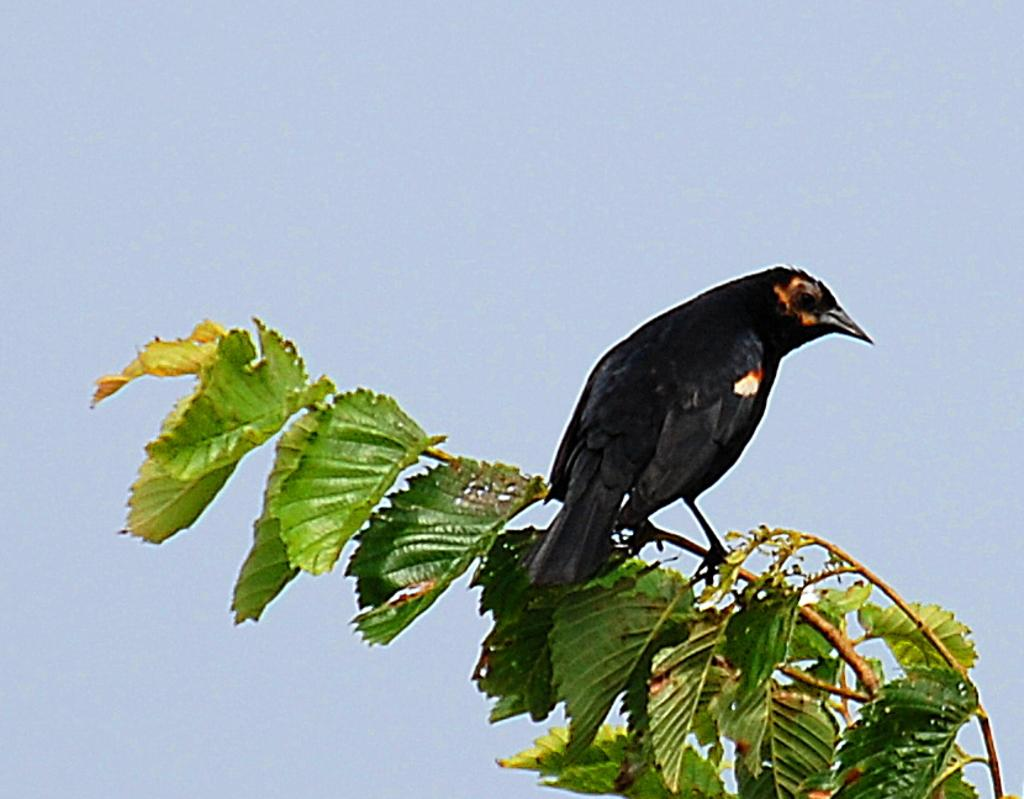What type of animal is in the foreground of the image? There is a black bird in the foreground of the image. Where is the bird located? The bird is on a branch. What can be seen on the branch besides the bird? There are leaves on the branch. What is visible in the background of the image? The sky is visible in the background of the image. What type of scent can be detected from the bird in the image? There is no information about the scent of the bird in the image, as it is a visual representation. 